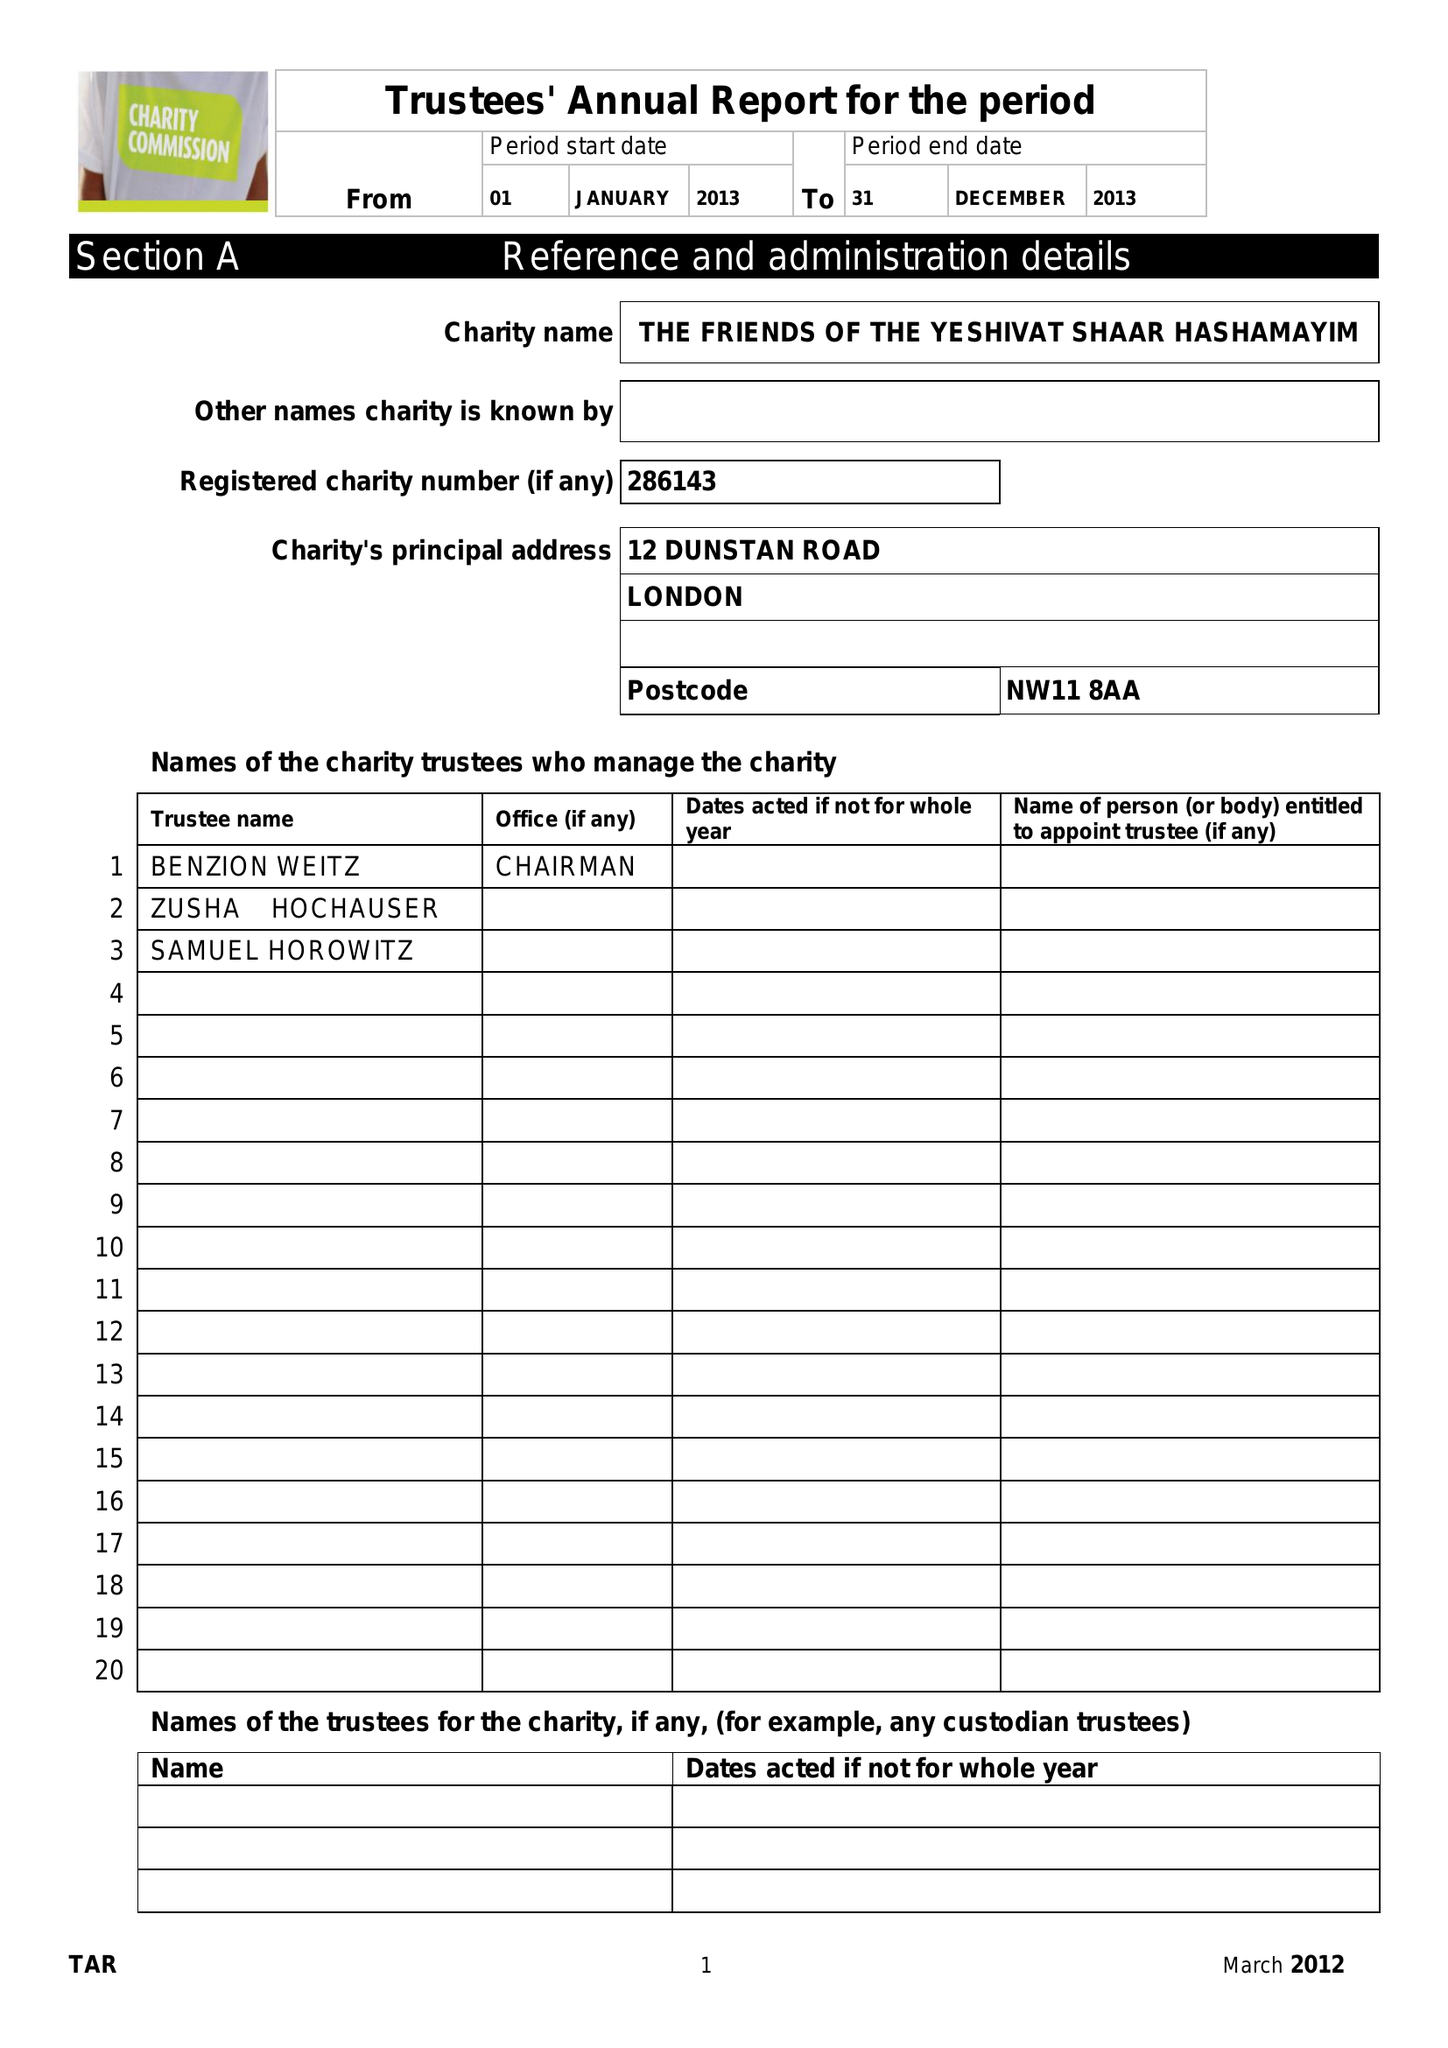What is the value for the income_annually_in_british_pounds?
Answer the question using a single word or phrase. 75519.00 